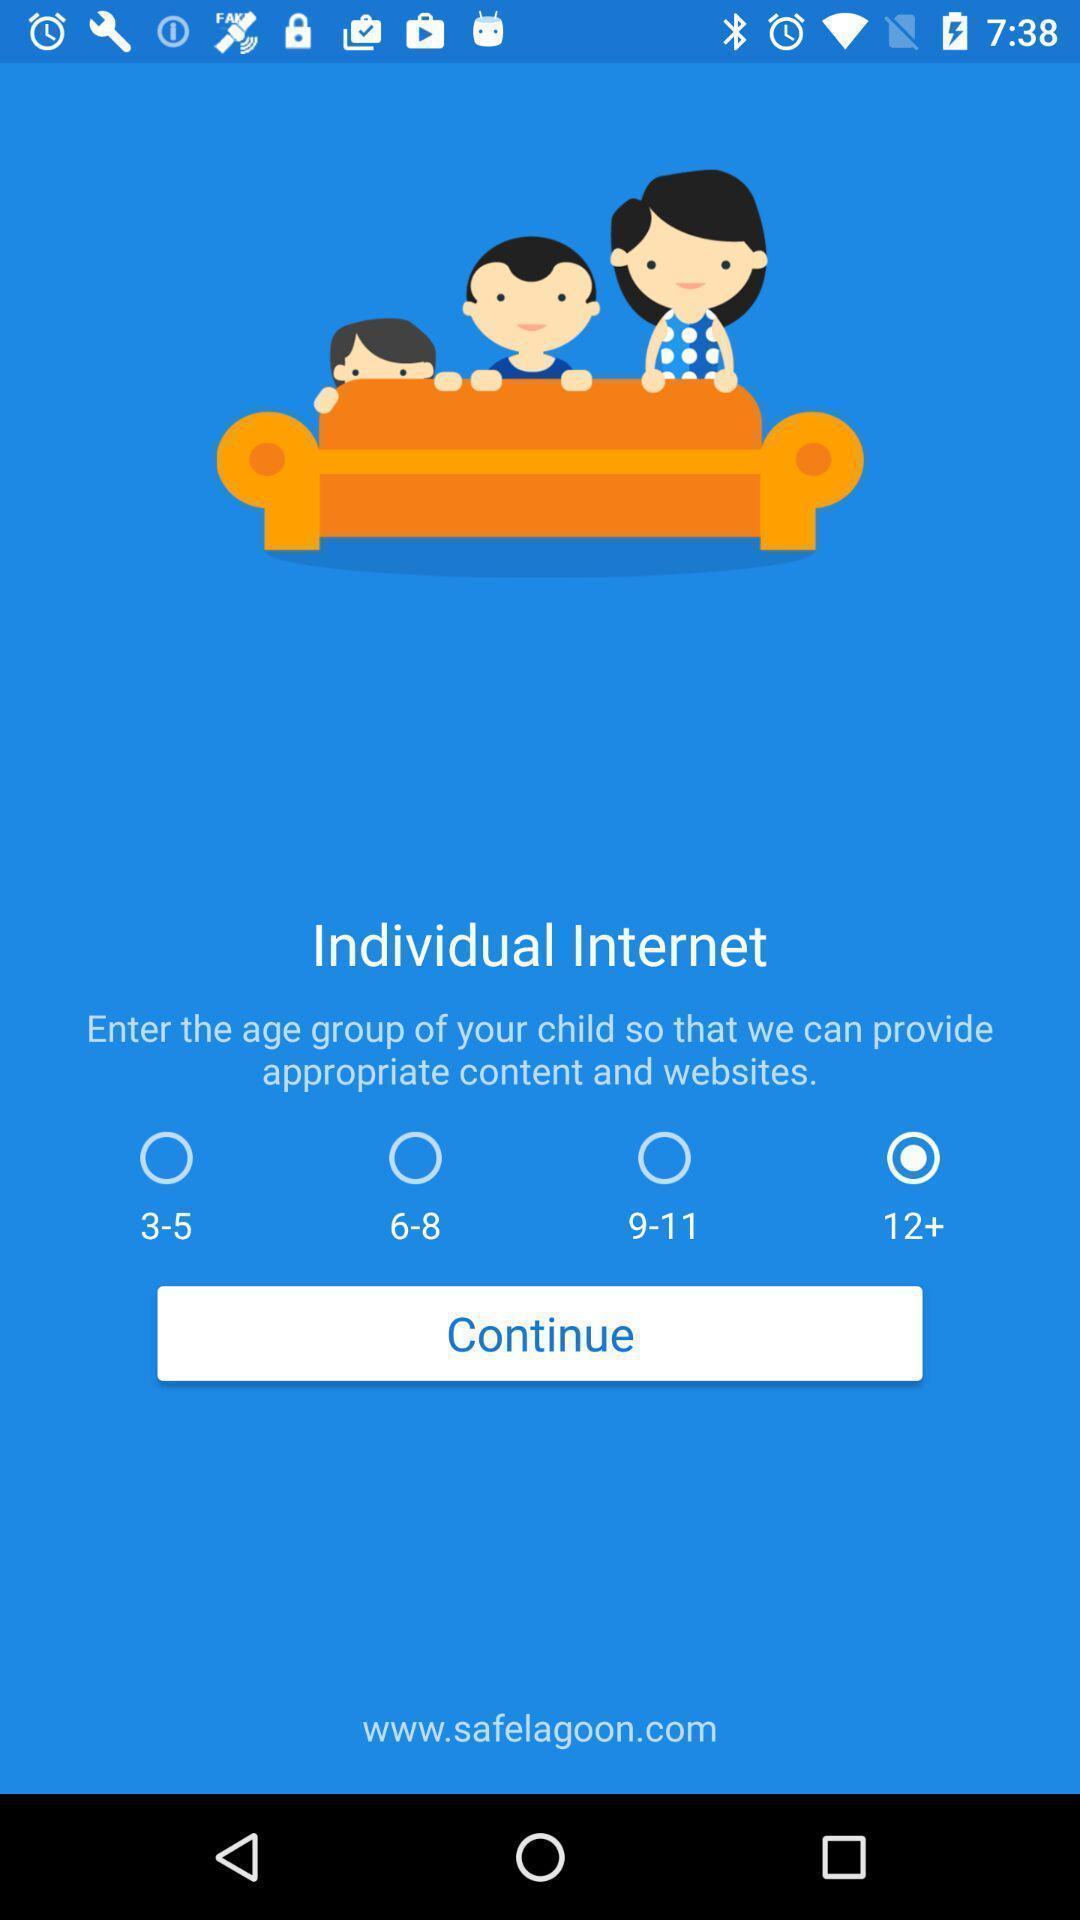Summarize the information in this screenshot. Page for selecting an age for an app. 